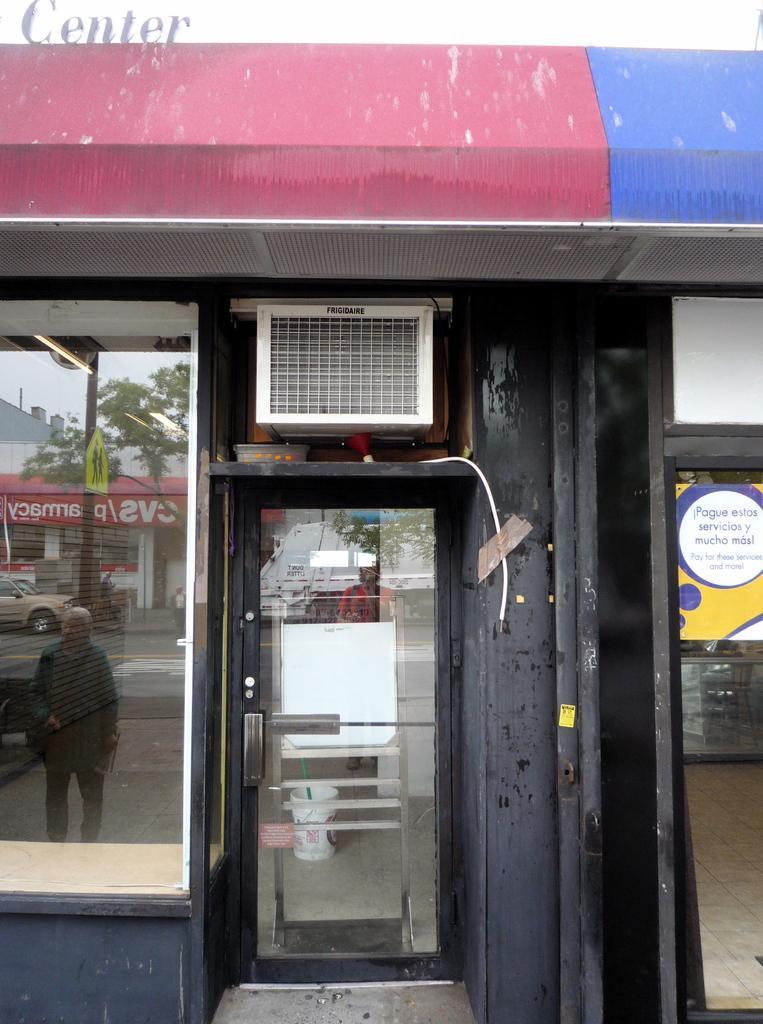Describe this image in one or two sentences. In this picture we can see a door, bucket, poster, signboard, pole, car and a person walking on the road, buildings, trees. 